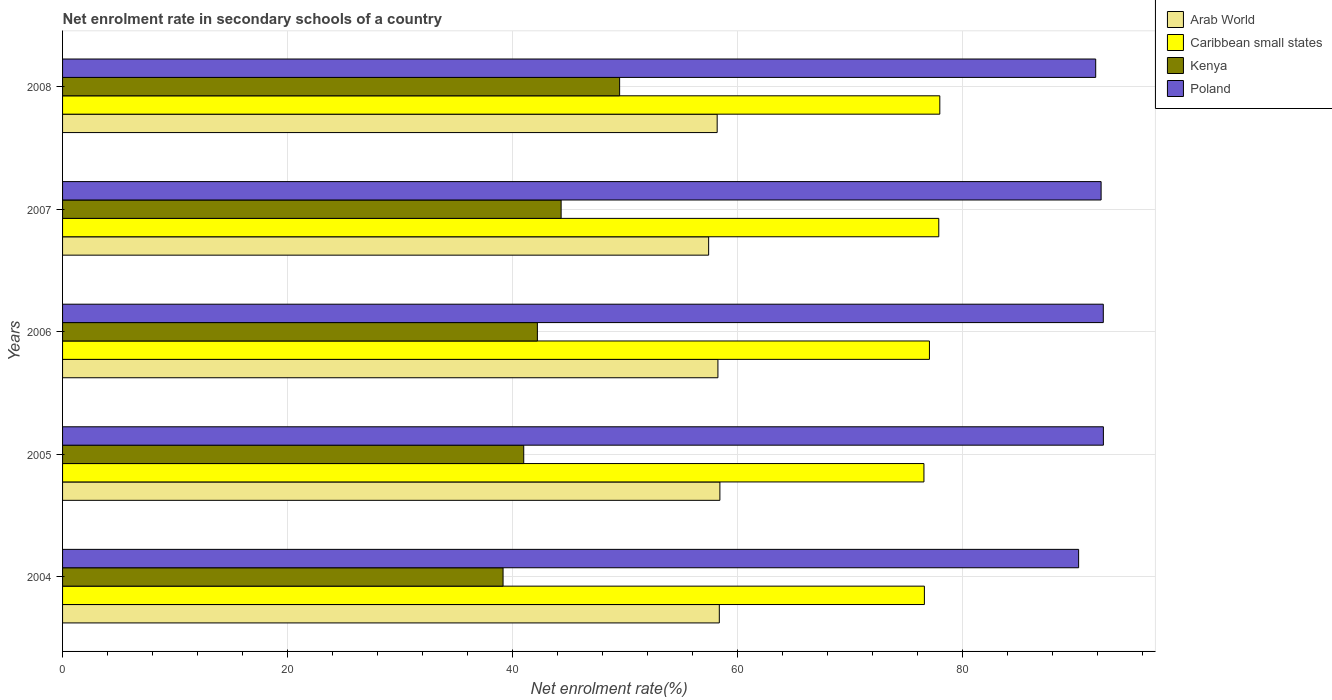How many different coloured bars are there?
Provide a succinct answer. 4. Are the number of bars on each tick of the Y-axis equal?
Your response must be concise. Yes. What is the net enrolment rate in secondary schools in Kenya in 2006?
Ensure brevity in your answer.  42.21. Across all years, what is the maximum net enrolment rate in secondary schools in Arab World?
Offer a terse response. 58.44. Across all years, what is the minimum net enrolment rate in secondary schools in Poland?
Provide a short and direct response. 90.33. In which year was the net enrolment rate in secondary schools in Poland minimum?
Give a very brief answer. 2004. What is the total net enrolment rate in secondary schools in Poland in the graph?
Provide a succinct answer. 459.57. What is the difference between the net enrolment rate in secondary schools in Kenya in 2005 and that in 2006?
Provide a short and direct response. -1.21. What is the difference between the net enrolment rate in secondary schools in Poland in 2006 and the net enrolment rate in secondary schools in Arab World in 2005?
Offer a terse response. 34.09. What is the average net enrolment rate in secondary schools in Kenya per year?
Provide a short and direct response. 43.24. In the year 2008, what is the difference between the net enrolment rate in secondary schools in Arab World and net enrolment rate in secondary schools in Kenya?
Provide a short and direct response. 8.67. In how many years, is the net enrolment rate in secondary schools in Kenya greater than 72 %?
Give a very brief answer. 0. What is the ratio of the net enrolment rate in secondary schools in Arab World in 2004 to that in 2006?
Your answer should be compact. 1. Is the difference between the net enrolment rate in secondary schools in Arab World in 2007 and 2008 greater than the difference between the net enrolment rate in secondary schools in Kenya in 2007 and 2008?
Keep it short and to the point. Yes. What is the difference between the highest and the second highest net enrolment rate in secondary schools in Caribbean small states?
Ensure brevity in your answer.  0.09. What is the difference between the highest and the lowest net enrolment rate in secondary schools in Poland?
Your response must be concise. 2.2. What does the 1st bar from the top in 2008 represents?
Ensure brevity in your answer.  Poland. What does the 2nd bar from the bottom in 2008 represents?
Offer a terse response. Caribbean small states. Is it the case that in every year, the sum of the net enrolment rate in secondary schools in Poland and net enrolment rate in secondary schools in Arab World is greater than the net enrolment rate in secondary schools in Caribbean small states?
Give a very brief answer. Yes. How many years are there in the graph?
Offer a terse response. 5. What is the difference between two consecutive major ticks on the X-axis?
Your answer should be very brief. 20. How are the legend labels stacked?
Provide a short and direct response. Vertical. What is the title of the graph?
Make the answer very short. Net enrolment rate in secondary schools of a country. What is the label or title of the X-axis?
Your answer should be compact. Net enrolment rate(%). What is the label or title of the Y-axis?
Provide a short and direct response. Years. What is the Net enrolment rate(%) of Arab World in 2004?
Your answer should be compact. 58.39. What is the Net enrolment rate(%) of Caribbean small states in 2004?
Your answer should be compact. 76.62. What is the Net enrolment rate(%) in Kenya in 2004?
Your response must be concise. 39.16. What is the Net enrolment rate(%) of Poland in 2004?
Offer a terse response. 90.33. What is the Net enrolment rate(%) in Arab World in 2005?
Ensure brevity in your answer.  58.44. What is the Net enrolment rate(%) in Caribbean small states in 2005?
Make the answer very short. 76.58. What is the Net enrolment rate(%) of Kenya in 2005?
Offer a very short reply. 41. What is the Net enrolment rate(%) of Poland in 2005?
Your response must be concise. 92.53. What is the Net enrolment rate(%) in Arab World in 2006?
Your answer should be compact. 58.26. What is the Net enrolment rate(%) in Caribbean small states in 2006?
Your answer should be very brief. 77.07. What is the Net enrolment rate(%) of Kenya in 2006?
Offer a very short reply. 42.21. What is the Net enrolment rate(%) of Poland in 2006?
Offer a very short reply. 92.52. What is the Net enrolment rate(%) in Arab World in 2007?
Your response must be concise. 57.44. What is the Net enrolment rate(%) of Caribbean small states in 2007?
Keep it short and to the point. 77.9. What is the Net enrolment rate(%) in Kenya in 2007?
Your answer should be compact. 44.32. What is the Net enrolment rate(%) in Poland in 2007?
Keep it short and to the point. 92.33. What is the Net enrolment rate(%) in Arab World in 2008?
Offer a terse response. 58.2. What is the Net enrolment rate(%) of Caribbean small states in 2008?
Make the answer very short. 77.99. What is the Net enrolment rate(%) of Kenya in 2008?
Provide a short and direct response. 49.52. What is the Net enrolment rate(%) of Poland in 2008?
Offer a terse response. 91.85. Across all years, what is the maximum Net enrolment rate(%) in Arab World?
Your answer should be compact. 58.44. Across all years, what is the maximum Net enrolment rate(%) in Caribbean small states?
Your answer should be very brief. 77.99. Across all years, what is the maximum Net enrolment rate(%) of Kenya?
Your response must be concise. 49.52. Across all years, what is the maximum Net enrolment rate(%) of Poland?
Provide a short and direct response. 92.53. Across all years, what is the minimum Net enrolment rate(%) of Arab World?
Offer a terse response. 57.44. Across all years, what is the minimum Net enrolment rate(%) of Caribbean small states?
Keep it short and to the point. 76.58. Across all years, what is the minimum Net enrolment rate(%) in Kenya?
Offer a terse response. 39.16. Across all years, what is the minimum Net enrolment rate(%) in Poland?
Provide a short and direct response. 90.33. What is the total Net enrolment rate(%) of Arab World in the graph?
Keep it short and to the point. 290.72. What is the total Net enrolment rate(%) in Caribbean small states in the graph?
Your answer should be very brief. 386.16. What is the total Net enrolment rate(%) of Kenya in the graph?
Offer a terse response. 216.22. What is the total Net enrolment rate(%) in Poland in the graph?
Offer a terse response. 459.57. What is the difference between the Net enrolment rate(%) in Arab World in 2004 and that in 2005?
Offer a terse response. -0.05. What is the difference between the Net enrolment rate(%) in Caribbean small states in 2004 and that in 2005?
Your answer should be compact. 0.04. What is the difference between the Net enrolment rate(%) in Kenya in 2004 and that in 2005?
Your answer should be very brief. -1.84. What is the difference between the Net enrolment rate(%) in Poland in 2004 and that in 2005?
Your response must be concise. -2.2. What is the difference between the Net enrolment rate(%) of Arab World in 2004 and that in 2006?
Offer a terse response. 0.12. What is the difference between the Net enrolment rate(%) of Caribbean small states in 2004 and that in 2006?
Your response must be concise. -0.45. What is the difference between the Net enrolment rate(%) of Kenya in 2004 and that in 2006?
Keep it short and to the point. -3.05. What is the difference between the Net enrolment rate(%) in Poland in 2004 and that in 2006?
Your answer should be very brief. -2.19. What is the difference between the Net enrolment rate(%) in Arab World in 2004 and that in 2007?
Make the answer very short. 0.95. What is the difference between the Net enrolment rate(%) of Caribbean small states in 2004 and that in 2007?
Provide a succinct answer. -1.28. What is the difference between the Net enrolment rate(%) of Kenya in 2004 and that in 2007?
Your response must be concise. -5.16. What is the difference between the Net enrolment rate(%) in Poland in 2004 and that in 2007?
Your answer should be compact. -2. What is the difference between the Net enrolment rate(%) in Arab World in 2004 and that in 2008?
Ensure brevity in your answer.  0.19. What is the difference between the Net enrolment rate(%) in Caribbean small states in 2004 and that in 2008?
Keep it short and to the point. -1.37. What is the difference between the Net enrolment rate(%) of Kenya in 2004 and that in 2008?
Your response must be concise. -10.36. What is the difference between the Net enrolment rate(%) in Poland in 2004 and that in 2008?
Your answer should be very brief. -1.52. What is the difference between the Net enrolment rate(%) in Arab World in 2005 and that in 2006?
Ensure brevity in your answer.  0.17. What is the difference between the Net enrolment rate(%) of Caribbean small states in 2005 and that in 2006?
Provide a succinct answer. -0.49. What is the difference between the Net enrolment rate(%) of Kenya in 2005 and that in 2006?
Offer a very short reply. -1.21. What is the difference between the Net enrolment rate(%) of Poland in 2005 and that in 2006?
Your answer should be very brief. 0.01. What is the difference between the Net enrolment rate(%) of Arab World in 2005 and that in 2007?
Make the answer very short. 1. What is the difference between the Net enrolment rate(%) of Caribbean small states in 2005 and that in 2007?
Your response must be concise. -1.32. What is the difference between the Net enrolment rate(%) of Kenya in 2005 and that in 2007?
Your answer should be very brief. -3.32. What is the difference between the Net enrolment rate(%) in Poland in 2005 and that in 2007?
Keep it short and to the point. 0.2. What is the difference between the Net enrolment rate(%) in Arab World in 2005 and that in 2008?
Give a very brief answer. 0.24. What is the difference between the Net enrolment rate(%) in Caribbean small states in 2005 and that in 2008?
Your answer should be very brief. -1.41. What is the difference between the Net enrolment rate(%) of Kenya in 2005 and that in 2008?
Provide a short and direct response. -8.52. What is the difference between the Net enrolment rate(%) of Poland in 2005 and that in 2008?
Your answer should be very brief. 0.68. What is the difference between the Net enrolment rate(%) of Arab World in 2006 and that in 2007?
Your answer should be compact. 0.83. What is the difference between the Net enrolment rate(%) in Caribbean small states in 2006 and that in 2007?
Keep it short and to the point. -0.83. What is the difference between the Net enrolment rate(%) in Kenya in 2006 and that in 2007?
Offer a terse response. -2.11. What is the difference between the Net enrolment rate(%) in Poland in 2006 and that in 2007?
Provide a succinct answer. 0.19. What is the difference between the Net enrolment rate(%) of Arab World in 2006 and that in 2008?
Keep it short and to the point. 0.07. What is the difference between the Net enrolment rate(%) of Caribbean small states in 2006 and that in 2008?
Your answer should be very brief. -0.92. What is the difference between the Net enrolment rate(%) of Kenya in 2006 and that in 2008?
Offer a very short reply. -7.31. What is the difference between the Net enrolment rate(%) of Poland in 2006 and that in 2008?
Your answer should be very brief. 0.67. What is the difference between the Net enrolment rate(%) of Arab World in 2007 and that in 2008?
Your answer should be compact. -0.76. What is the difference between the Net enrolment rate(%) in Caribbean small states in 2007 and that in 2008?
Offer a terse response. -0.09. What is the difference between the Net enrolment rate(%) in Kenya in 2007 and that in 2008?
Provide a succinct answer. -5.2. What is the difference between the Net enrolment rate(%) of Poland in 2007 and that in 2008?
Ensure brevity in your answer.  0.48. What is the difference between the Net enrolment rate(%) of Arab World in 2004 and the Net enrolment rate(%) of Caribbean small states in 2005?
Give a very brief answer. -18.19. What is the difference between the Net enrolment rate(%) of Arab World in 2004 and the Net enrolment rate(%) of Kenya in 2005?
Keep it short and to the point. 17.39. What is the difference between the Net enrolment rate(%) of Arab World in 2004 and the Net enrolment rate(%) of Poland in 2005?
Keep it short and to the point. -34.15. What is the difference between the Net enrolment rate(%) in Caribbean small states in 2004 and the Net enrolment rate(%) in Kenya in 2005?
Keep it short and to the point. 35.62. What is the difference between the Net enrolment rate(%) in Caribbean small states in 2004 and the Net enrolment rate(%) in Poland in 2005?
Ensure brevity in your answer.  -15.91. What is the difference between the Net enrolment rate(%) in Kenya in 2004 and the Net enrolment rate(%) in Poland in 2005?
Ensure brevity in your answer.  -53.37. What is the difference between the Net enrolment rate(%) in Arab World in 2004 and the Net enrolment rate(%) in Caribbean small states in 2006?
Provide a succinct answer. -18.68. What is the difference between the Net enrolment rate(%) in Arab World in 2004 and the Net enrolment rate(%) in Kenya in 2006?
Ensure brevity in your answer.  16.17. What is the difference between the Net enrolment rate(%) of Arab World in 2004 and the Net enrolment rate(%) of Poland in 2006?
Keep it short and to the point. -34.14. What is the difference between the Net enrolment rate(%) of Caribbean small states in 2004 and the Net enrolment rate(%) of Kenya in 2006?
Your answer should be very brief. 34.41. What is the difference between the Net enrolment rate(%) of Caribbean small states in 2004 and the Net enrolment rate(%) of Poland in 2006?
Your response must be concise. -15.91. What is the difference between the Net enrolment rate(%) in Kenya in 2004 and the Net enrolment rate(%) in Poland in 2006?
Provide a short and direct response. -53.36. What is the difference between the Net enrolment rate(%) of Arab World in 2004 and the Net enrolment rate(%) of Caribbean small states in 2007?
Provide a succinct answer. -19.51. What is the difference between the Net enrolment rate(%) of Arab World in 2004 and the Net enrolment rate(%) of Kenya in 2007?
Make the answer very short. 14.06. What is the difference between the Net enrolment rate(%) in Arab World in 2004 and the Net enrolment rate(%) in Poland in 2007?
Your response must be concise. -33.94. What is the difference between the Net enrolment rate(%) of Caribbean small states in 2004 and the Net enrolment rate(%) of Kenya in 2007?
Your answer should be very brief. 32.29. What is the difference between the Net enrolment rate(%) in Caribbean small states in 2004 and the Net enrolment rate(%) in Poland in 2007?
Offer a very short reply. -15.71. What is the difference between the Net enrolment rate(%) in Kenya in 2004 and the Net enrolment rate(%) in Poland in 2007?
Ensure brevity in your answer.  -53.17. What is the difference between the Net enrolment rate(%) of Arab World in 2004 and the Net enrolment rate(%) of Caribbean small states in 2008?
Ensure brevity in your answer.  -19.6. What is the difference between the Net enrolment rate(%) in Arab World in 2004 and the Net enrolment rate(%) in Kenya in 2008?
Offer a very short reply. 8.86. What is the difference between the Net enrolment rate(%) of Arab World in 2004 and the Net enrolment rate(%) of Poland in 2008?
Keep it short and to the point. -33.46. What is the difference between the Net enrolment rate(%) in Caribbean small states in 2004 and the Net enrolment rate(%) in Kenya in 2008?
Your response must be concise. 27.09. What is the difference between the Net enrolment rate(%) in Caribbean small states in 2004 and the Net enrolment rate(%) in Poland in 2008?
Provide a short and direct response. -15.23. What is the difference between the Net enrolment rate(%) of Kenya in 2004 and the Net enrolment rate(%) of Poland in 2008?
Your answer should be compact. -52.69. What is the difference between the Net enrolment rate(%) of Arab World in 2005 and the Net enrolment rate(%) of Caribbean small states in 2006?
Provide a succinct answer. -18.63. What is the difference between the Net enrolment rate(%) of Arab World in 2005 and the Net enrolment rate(%) of Kenya in 2006?
Give a very brief answer. 16.23. What is the difference between the Net enrolment rate(%) in Arab World in 2005 and the Net enrolment rate(%) in Poland in 2006?
Your response must be concise. -34.09. What is the difference between the Net enrolment rate(%) of Caribbean small states in 2005 and the Net enrolment rate(%) of Kenya in 2006?
Give a very brief answer. 34.37. What is the difference between the Net enrolment rate(%) in Caribbean small states in 2005 and the Net enrolment rate(%) in Poland in 2006?
Offer a terse response. -15.94. What is the difference between the Net enrolment rate(%) of Kenya in 2005 and the Net enrolment rate(%) of Poland in 2006?
Give a very brief answer. -51.52. What is the difference between the Net enrolment rate(%) of Arab World in 2005 and the Net enrolment rate(%) of Caribbean small states in 2007?
Your answer should be very brief. -19.46. What is the difference between the Net enrolment rate(%) in Arab World in 2005 and the Net enrolment rate(%) in Kenya in 2007?
Give a very brief answer. 14.11. What is the difference between the Net enrolment rate(%) of Arab World in 2005 and the Net enrolment rate(%) of Poland in 2007?
Give a very brief answer. -33.89. What is the difference between the Net enrolment rate(%) of Caribbean small states in 2005 and the Net enrolment rate(%) of Kenya in 2007?
Give a very brief answer. 32.26. What is the difference between the Net enrolment rate(%) in Caribbean small states in 2005 and the Net enrolment rate(%) in Poland in 2007?
Your response must be concise. -15.75. What is the difference between the Net enrolment rate(%) of Kenya in 2005 and the Net enrolment rate(%) of Poland in 2007?
Give a very brief answer. -51.33. What is the difference between the Net enrolment rate(%) of Arab World in 2005 and the Net enrolment rate(%) of Caribbean small states in 2008?
Your answer should be very brief. -19.55. What is the difference between the Net enrolment rate(%) in Arab World in 2005 and the Net enrolment rate(%) in Kenya in 2008?
Keep it short and to the point. 8.91. What is the difference between the Net enrolment rate(%) of Arab World in 2005 and the Net enrolment rate(%) of Poland in 2008?
Give a very brief answer. -33.41. What is the difference between the Net enrolment rate(%) of Caribbean small states in 2005 and the Net enrolment rate(%) of Kenya in 2008?
Keep it short and to the point. 27.05. What is the difference between the Net enrolment rate(%) of Caribbean small states in 2005 and the Net enrolment rate(%) of Poland in 2008?
Provide a succinct answer. -15.27. What is the difference between the Net enrolment rate(%) of Kenya in 2005 and the Net enrolment rate(%) of Poland in 2008?
Your answer should be compact. -50.85. What is the difference between the Net enrolment rate(%) in Arab World in 2006 and the Net enrolment rate(%) in Caribbean small states in 2007?
Your response must be concise. -19.64. What is the difference between the Net enrolment rate(%) in Arab World in 2006 and the Net enrolment rate(%) in Kenya in 2007?
Provide a succinct answer. 13.94. What is the difference between the Net enrolment rate(%) in Arab World in 2006 and the Net enrolment rate(%) in Poland in 2007?
Provide a short and direct response. -34.07. What is the difference between the Net enrolment rate(%) of Caribbean small states in 2006 and the Net enrolment rate(%) of Kenya in 2007?
Offer a terse response. 32.74. What is the difference between the Net enrolment rate(%) of Caribbean small states in 2006 and the Net enrolment rate(%) of Poland in 2007?
Provide a succinct answer. -15.26. What is the difference between the Net enrolment rate(%) in Kenya in 2006 and the Net enrolment rate(%) in Poland in 2007?
Ensure brevity in your answer.  -50.12. What is the difference between the Net enrolment rate(%) of Arab World in 2006 and the Net enrolment rate(%) of Caribbean small states in 2008?
Give a very brief answer. -19.73. What is the difference between the Net enrolment rate(%) of Arab World in 2006 and the Net enrolment rate(%) of Kenya in 2008?
Your answer should be compact. 8.74. What is the difference between the Net enrolment rate(%) in Arab World in 2006 and the Net enrolment rate(%) in Poland in 2008?
Ensure brevity in your answer.  -33.59. What is the difference between the Net enrolment rate(%) of Caribbean small states in 2006 and the Net enrolment rate(%) of Kenya in 2008?
Provide a succinct answer. 27.54. What is the difference between the Net enrolment rate(%) of Caribbean small states in 2006 and the Net enrolment rate(%) of Poland in 2008?
Ensure brevity in your answer.  -14.78. What is the difference between the Net enrolment rate(%) of Kenya in 2006 and the Net enrolment rate(%) of Poland in 2008?
Your response must be concise. -49.64. What is the difference between the Net enrolment rate(%) in Arab World in 2007 and the Net enrolment rate(%) in Caribbean small states in 2008?
Provide a short and direct response. -20.55. What is the difference between the Net enrolment rate(%) of Arab World in 2007 and the Net enrolment rate(%) of Kenya in 2008?
Provide a short and direct response. 7.91. What is the difference between the Net enrolment rate(%) in Arab World in 2007 and the Net enrolment rate(%) in Poland in 2008?
Make the answer very short. -34.41. What is the difference between the Net enrolment rate(%) of Caribbean small states in 2007 and the Net enrolment rate(%) of Kenya in 2008?
Your response must be concise. 28.37. What is the difference between the Net enrolment rate(%) of Caribbean small states in 2007 and the Net enrolment rate(%) of Poland in 2008?
Offer a very short reply. -13.95. What is the difference between the Net enrolment rate(%) of Kenya in 2007 and the Net enrolment rate(%) of Poland in 2008?
Your answer should be compact. -47.53. What is the average Net enrolment rate(%) of Arab World per year?
Your answer should be compact. 58.14. What is the average Net enrolment rate(%) in Caribbean small states per year?
Your answer should be very brief. 77.23. What is the average Net enrolment rate(%) in Kenya per year?
Ensure brevity in your answer.  43.24. What is the average Net enrolment rate(%) of Poland per year?
Provide a short and direct response. 91.91. In the year 2004, what is the difference between the Net enrolment rate(%) in Arab World and Net enrolment rate(%) in Caribbean small states?
Your answer should be compact. -18.23. In the year 2004, what is the difference between the Net enrolment rate(%) in Arab World and Net enrolment rate(%) in Kenya?
Your answer should be compact. 19.23. In the year 2004, what is the difference between the Net enrolment rate(%) of Arab World and Net enrolment rate(%) of Poland?
Provide a succinct answer. -31.94. In the year 2004, what is the difference between the Net enrolment rate(%) in Caribbean small states and Net enrolment rate(%) in Kenya?
Ensure brevity in your answer.  37.46. In the year 2004, what is the difference between the Net enrolment rate(%) of Caribbean small states and Net enrolment rate(%) of Poland?
Keep it short and to the point. -13.71. In the year 2004, what is the difference between the Net enrolment rate(%) of Kenya and Net enrolment rate(%) of Poland?
Give a very brief answer. -51.17. In the year 2005, what is the difference between the Net enrolment rate(%) of Arab World and Net enrolment rate(%) of Caribbean small states?
Your response must be concise. -18.14. In the year 2005, what is the difference between the Net enrolment rate(%) in Arab World and Net enrolment rate(%) in Kenya?
Keep it short and to the point. 17.44. In the year 2005, what is the difference between the Net enrolment rate(%) of Arab World and Net enrolment rate(%) of Poland?
Make the answer very short. -34.09. In the year 2005, what is the difference between the Net enrolment rate(%) of Caribbean small states and Net enrolment rate(%) of Kenya?
Offer a terse response. 35.58. In the year 2005, what is the difference between the Net enrolment rate(%) of Caribbean small states and Net enrolment rate(%) of Poland?
Keep it short and to the point. -15.95. In the year 2005, what is the difference between the Net enrolment rate(%) of Kenya and Net enrolment rate(%) of Poland?
Your answer should be compact. -51.53. In the year 2006, what is the difference between the Net enrolment rate(%) in Arab World and Net enrolment rate(%) in Caribbean small states?
Your answer should be compact. -18.81. In the year 2006, what is the difference between the Net enrolment rate(%) in Arab World and Net enrolment rate(%) in Kenya?
Provide a short and direct response. 16.05. In the year 2006, what is the difference between the Net enrolment rate(%) of Arab World and Net enrolment rate(%) of Poland?
Give a very brief answer. -34.26. In the year 2006, what is the difference between the Net enrolment rate(%) in Caribbean small states and Net enrolment rate(%) in Kenya?
Offer a terse response. 34.86. In the year 2006, what is the difference between the Net enrolment rate(%) in Caribbean small states and Net enrolment rate(%) in Poland?
Your answer should be very brief. -15.46. In the year 2006, what is the difference between the Net enrolment rate(%) of Kenya and Net enrolment rate(%) of Poland?
Your response must be concise. -50.31. In the year 2007, what is the difference between the Net enrolment rate(%) in Arab World and Net enrolment rate(%) in Caribbean small states?
Give a very brief answer. -20.46. In the year 2007, what is the difference between the Net enrolment rate(%) in Arab World and Net enrolment rate(%) in Kenya?
Keep it short and to the point. 13.11. In the year 2007, what is the difference between the Net enrolment rate(%) of Arab World and Net enrolment rate(%) of Poland?
Keep it short and to the point. -34.89. In the year 2007, what is the difference between the Net enrolment rate(%) in Caribbean small states and Net enrolment rate(%) in Kenya?
Offer a very short reply. 33.57. In the year 2007, what is the difference between the Net enrolment rate(%) in Caribbean small states and Net enrolment rate(%) in Poland?
Provide a short and direct response. -14.43. In the year 2007, what is the difference between the Net enrolment rate(%) in Kenya and Net enrolment rate(%) in Poland?
Ensure brevity in your answer.  -48.01. In the year 2008, what is the difference between the Net enrolment rate(%) in Arab World and Net enrolment rate(%) in Caribbean small states?
Your answer should be very brief. -19.79. In the year 2008, what is the difference between the Net enrolment rate(%) in Arab World and Net enrolment rate(%) in Kenya?
Your response must be concise. 8.67. In the year 2008, what is the difference between the Net enrolment rate(%) of Arab World and Net enrolment rate(%) of Poland?
Give a very brief answer. -33.65. In the year 2008, what is the difference between the Net enrolment rate(%) in Caribbean small states and Net enrolment rate(%) in Kenya?
Your answer should be compact. 28.47. In the year 2008, what is the difference between the Net enrolment rate(%) of Caribbean small states and Net enrolment rate(%) of Poland?
Provide a succinct answer. -13.86. In the year 2008, what is the difference between the Net enrolment rate(%) of Kenya and Net enrolment rate(%) of Poland?
Provide a short and direct response. -42.32. What is the ratio of the Net enrolment rate(%) in Caribbean small states in 2004 to that in 2005?
Your answer should be compact. 1. What is the ratio of the Net enrolment rate(%) in Kenya in 2004 to that in 2005?
Your answer should be very brief. 0.96. What is the ratio of the Net enrolment rate(%) in Poland in 2004 to that in 2005?
Your answer should be very brief. 0.98. What is the ratio of the Net enrolment rate(%) of Arab World in 2004 to that in 2006?
Offer a very short reply. 1. What is the ratio of the Net enrolment rate(%) in Kenya in 2004 to that in 2006?
Your response must be concise. 0.93. What is the ratio of the Net enrolment rate(%) of Poland in 2004 to that in 2006?
Ensure brevity in your answer.  0.98. What is the ratio of the Net enrolment rate(%) in Arab World in 2004 to that in 2007?
Your answer should be compact. 1.02. What is the ratio of the Net enrolment rate(%) in Caribbean small states in 2004 to that in 2007?
Your response must be concise. 0.98. What is the ratio of the Net enrolment rate(%) of Kenya in 2004 to that in 2007?
Your answer should be very brief. 0.88. What is the ratio of the Net enrolment rate(%) in Poland in 2004 to that in 2007?
Your answer should be very brief. 0.98. What is the ratio of the Net enrolment rate(%) of Arab World in 2004 to that in 2008?
Provide a short and direct response. 1. What is the ratio of the Net enrolment rate(%) in Caribbean small states in 2004 to that in 2008?
Your answer should be compact. 0.98. What is the ratio of the Net enrolment rate(%) in Kenya in 2004 to that in 2008?
Your answer should be very brief. 0.79. What is the ratio of the Net enrolment rate(%) in Poland in 2004 to that in 2008?
Provide a succinct answer. 0.98. What is the ratio of the Net enrolment rate(%) in Arab World in 2005 to that in 2006?
Provide a short and direct response. 1. What is the ratio of the Net enrolment rate(%) of Kenya in 2005 to that in 2006?
Your answer should be very brief. 0.97. What is the ratio of the Net enrolment rate(%) in Arab World in 2005 to that in 2007?
Provide a short and direct response. 1.02. What is the ratio of the Net enrolment rate(%) of Caribbean small states in 2005 to that in 2007?
Provide a short and direct response. 0.98. What is the ratio of the Net enrolment rate(%) of Kenya in 2005 to that in 2007?
Ensure brevity in your answer.  0.93. What is the ratio of the Net enrolment rate(%) of Arab World in 2005 to that in 2008?
Give a very brief answer. 1. What is the ratio of the Net enrolment rate(%) in Caribbean small states in 2005 to that in 2008?
Ensure brevity in your answer.  0.98. What is the ratio of the Net enrolment rate(%) in Kenya in 2005 to that in 2008?
Provide a succinct answer. 0.83. What is the ratio of the Net enrolment rate(%) of Poland in 2005 to that in 2008?
Offer a very short reply. 1.01. What is the ratio of the Net enrolment rate(%) of Arab World in 2006 to that in 2007?
Offer a terse response. 1.01. What is the ratio of the Net enrolment rate(%) of Caribbean small states in 2006 to that in 2007?
Keep it short and to the point. 0.99. What is the ratio of the Net enrolment rate(%) of Kenya in 2006 to that in 2007?
Keep it short and to the point. 0.95. What is the ratio of the Net enrolment rate(%) of Poland in 2006 to that in 2007?
Offer a very short reply. 1. What is the ratio of the Net enrolment rate(%) of Arab World in 2006 to that in 2008?
Provide a succinct answer. 1. What is the ratio of the Net enrolment rate(%) in Caribbean small states in 2006 to that in 2008?
Provide a short and direct response. 0.99. What is the ratio of the Net enrolment rate(%) of Kenya in 2006 to that in 2008?
Keep it short and to the point. 0.85. What is the ratio of the Net enrolment rate(%) of Poland in 2006 to that in 2008?
Make the answer very short. 1.01. What is the ratio of the Net enrolment rate(%) of Arab World in 2007 to that in 2008?
Make the answer very short. 0.99. What is the ratio of the Net enrolment rate(%) in Kenya in 2007 to that in 2008?
Offer a terse response. 0.9. What is the difference between the highest and the second highest Net enrolment rate(%) in Arab World?
Your answer should be very brief. 0.05. What is the difference between the highest and the second highest Net enrolment rate(%) of Caribbean small states?
Make the answer very short. 0.09. What is the difference between the highest and the second highest Net enrolment rate(%) in Kenya?
Your answer should be compact. 5.2. What is the difference between the highest and the second highest Net enrolment rate(%) of Poland?
Ensure brevity in your answer.  0.01. What is the difference between the highest and the lowest Net enrolment rate(%) of Caribbean small states?
Provide a short and direct response. 1.41. What is the difference between the highest and the lowest Net enrolment rate(%) in Kenya?
Your response must be concise. 10.36. What is the difference between the highest and the lowest Net enrolment rate(%) in Poland?
Provide a short and direct response. 2.2. 